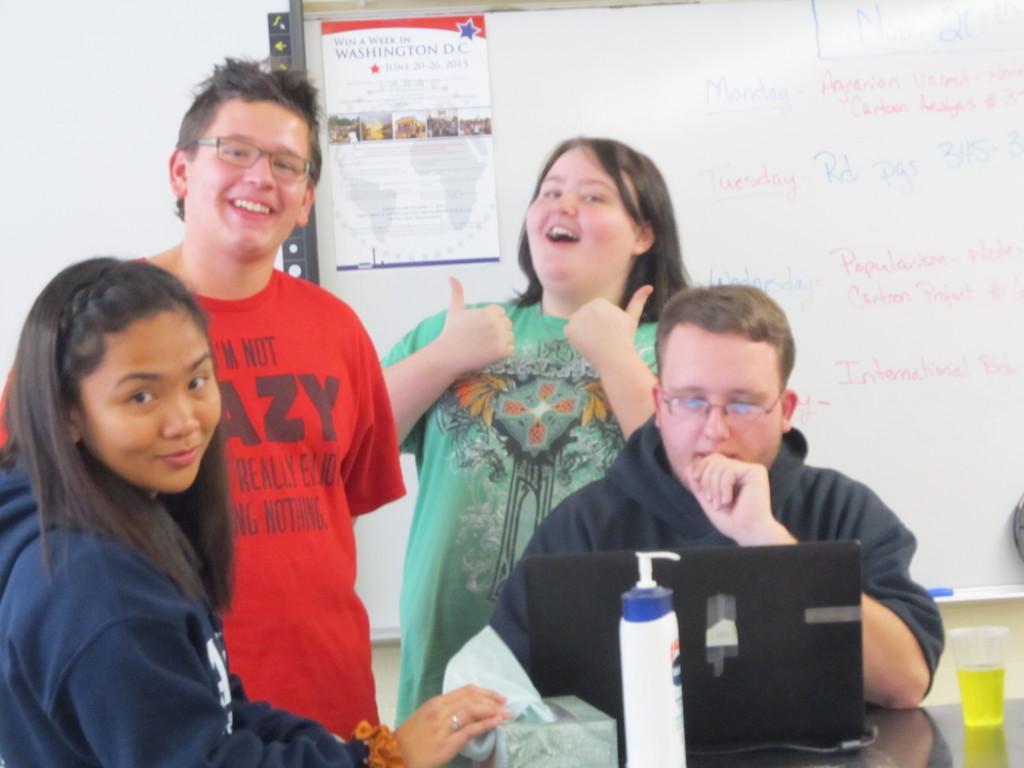How would you summarize this image in a sentence or two? In this picture we can observe four members. Two of them are standing and two of them are sitting in the chair. We can observe that two members are smiling. There is a person sitting in front of a laptop which is placed on the table. In the background there is a white color board. We can observe a wall on the left side. 